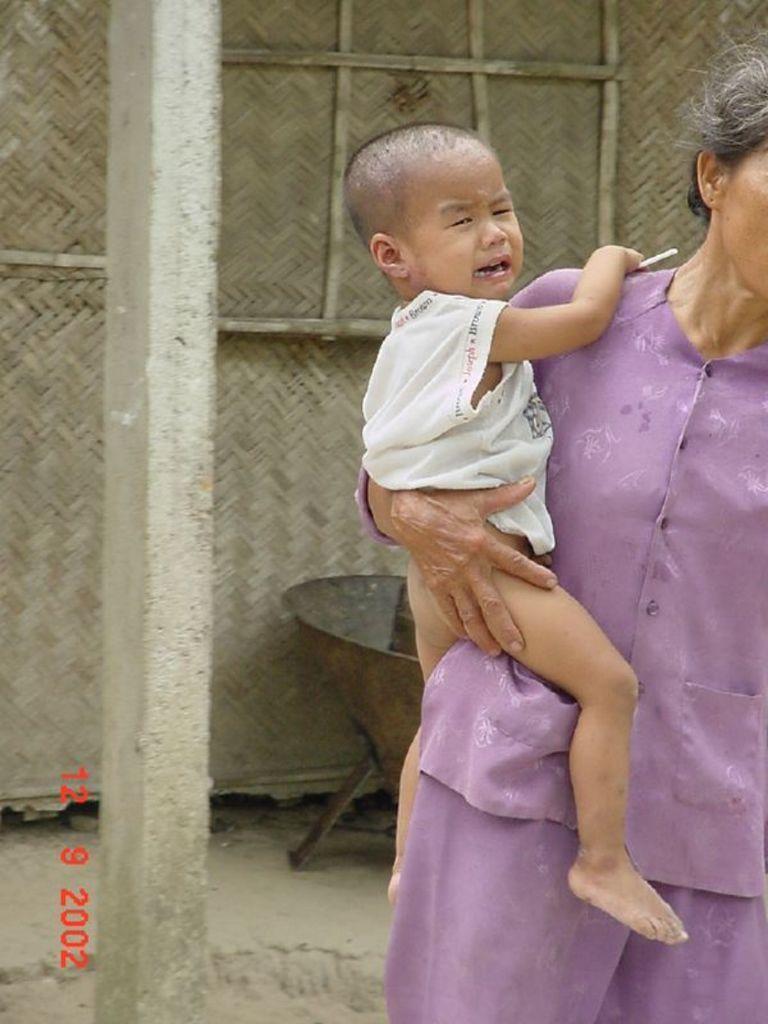Please provide a concise description of this image. The picture consists of a woman holding a baby. On the left there is a pole. In the background there is a thatched hut and an iron object. At the bottom there is sand. 